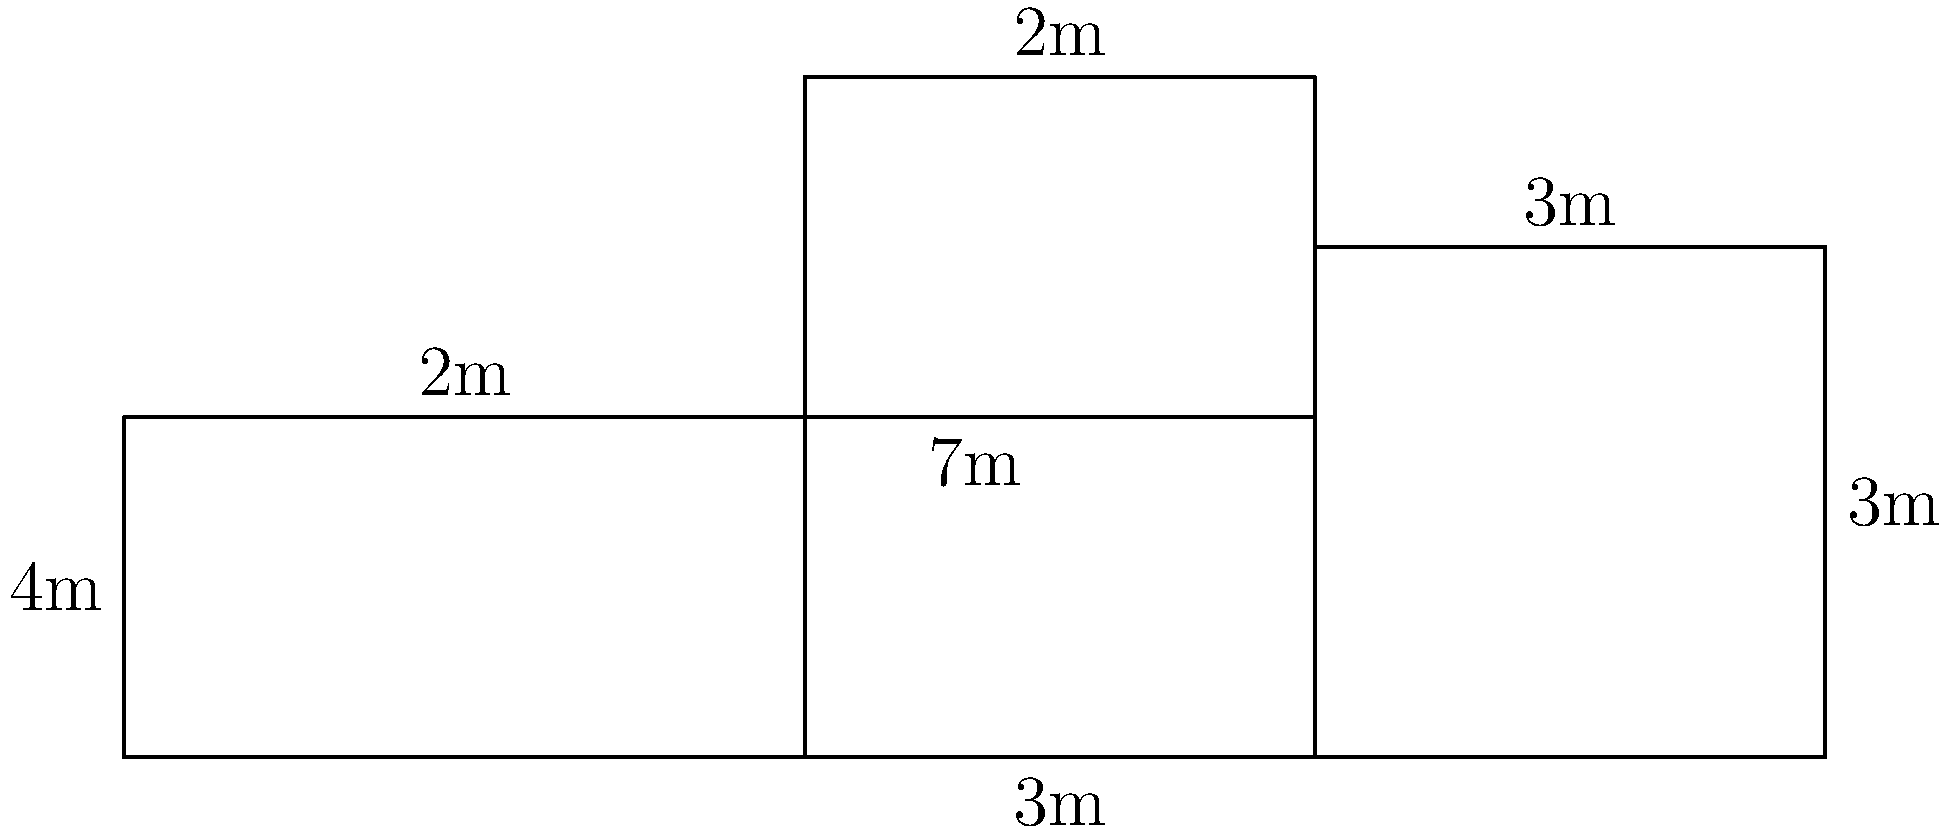At our local metro station, they've posted a simplified map of the station layout. It's made up of connected rectangles, as shown in the diagram. As we often discuss during our chats at the station, knowing the perimeter is crucial for emergency planning. Can you calculate the perimeter of the entire station layout based on this map? Let's calculate the perimeter step by step:

1) Start with the left side: $4$ m

2) Top side, from left to right:
   $2$ m + $3$ m + $2$ m + $3$ m = $10$ m

3) Right side: $3$ m

4) Bottom side, from right to left:
   $3$ m + $3$ m + $4$ m = $10$ m

5) Sum up all sides:
   $4$ m + $10$ m + $3$ m + $10$ m = $27$ m

Therefore, the total perimeter of the station layout is $27$ meters.
Answer: $27$ m 